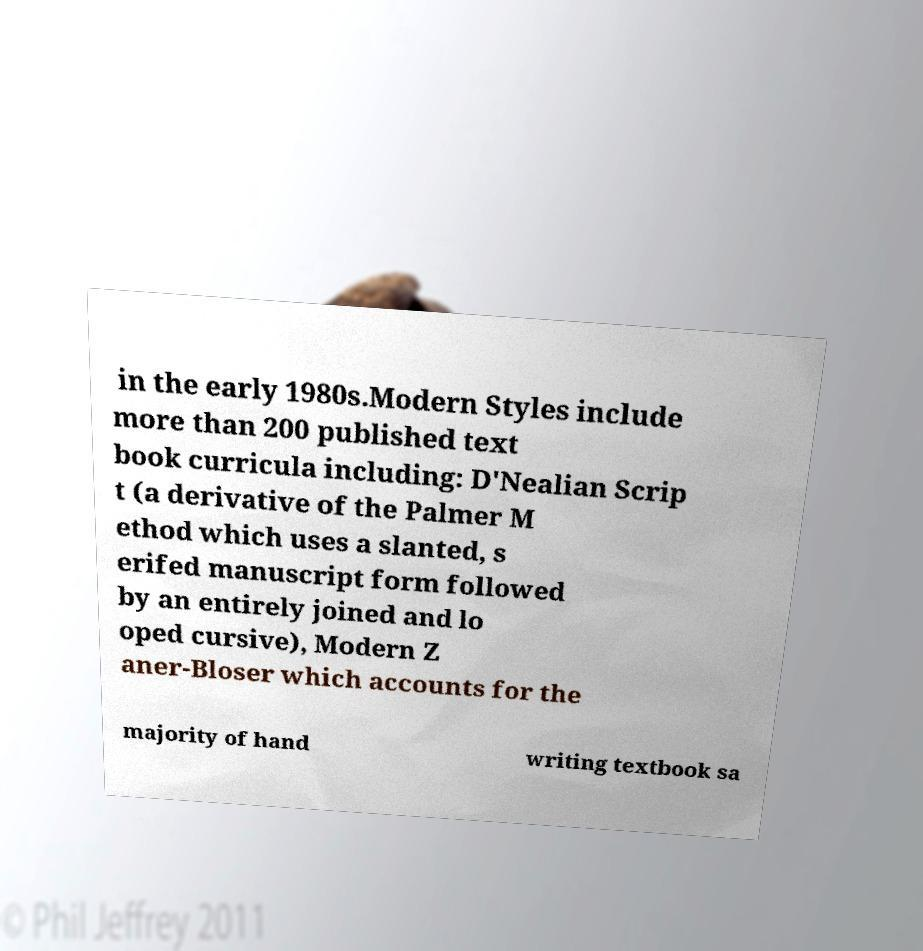Please identify and transcribe the text found in this image. in the early 1980s.Modern Styles include more than 200 published text book curricula including: D'Nealian Scrip t (a derivative of the Palmer M ethod which uses a slanted, s erifed manuscript form followed by an entirely joined and lo oped cursive), Modern Z aner-Bloser which accounts for the majority of hand writing textbook sa 